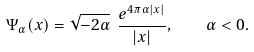<formula> <loc_0><loc_0><loc_500><loc_500>\Psi _ { \alpha } ( x ) = \sqrt { - 2 \alpha } \ \frac { e ^ { 4 \pi \alpha | x | } } { | x | } , \quad \alpha < 0 .</formula> 